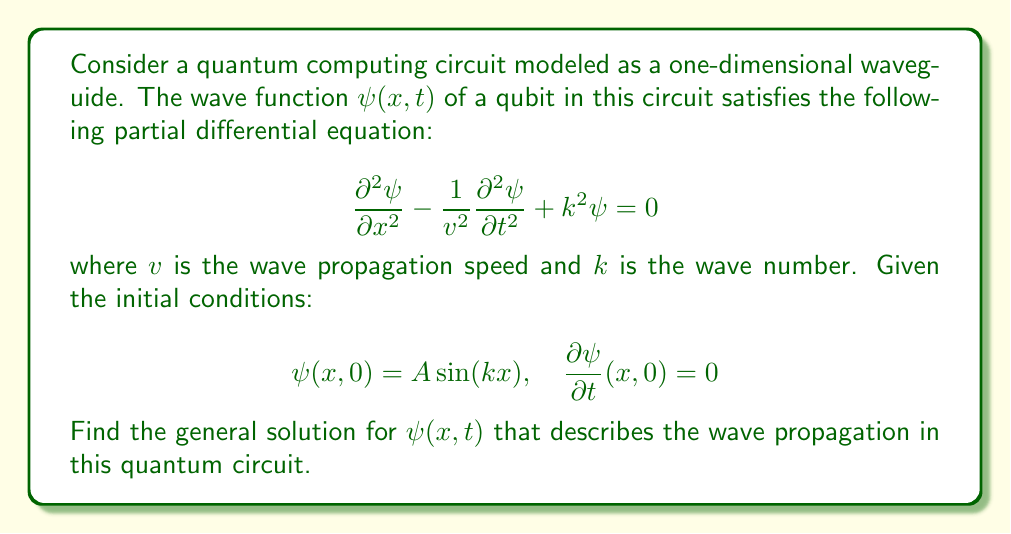Solve this math problem. To solve this problem, we'll follow these steps:

1) First, we recognize this equation as the Klein-Gordon equation, which describes relativistic wave propagation.

2) We can solve this using the method of separation of variables. Let's assume a solution of the form:

   $$\psi(x,t) = X(x)T(t)$$

3) Substituting this into our PDE:

   $$X''T - \frac{1}{v^2}XT'' + k^2XT = 0$$

4) Dividing by $XT$:

   $$\frac{X''}{X} - \frac{1}{v^2}\frac{T''}{T} + k^2 = 0$$

5) Since the left side is a function of $x$ only and the right side is a function of $t$ only, they must both equal a constant. Let's call this constant $-\omega^2$:

   $$\frac{X''}{X} + k^2 = \frac{1}{v^2}\frac{T''}{T} = -\omega^2$$

6) This gives us two ODEs:

   $$X'' + (k^2 + \omega^2)X = 0$$
   $$T'' + v^2\omega^2T = 0$$

7) The general solutions to these are:

   $$X(x) = C_1\sin(\sqrt{k^2 + \omega^2}x) + C_2\cos(\sqrt{k^2 + \omega^2}x)$$
   $$T(t) = C_3\sin(\omega vt) + C_4\cos(\omega vt)$$

8) Therefore, the general solution is:

   $$\psi(x,t) = [A_1\sin(\sqrt{k^2 + \omega^2}x) + A_2\cos(\sqrt{k^2 + \omega^2}x)][B_1\sin(\omega vt) + B_2\cos(\omega vt)]$$

9) Now, we apply the initial conditions. From $\psi(x,0) = A\sin(kx)$, we can deduce:

   $$A_2 = 0, \quad A_1B_2 = A, \quad \sqrt{k^2 + \omega^2} = k$$

10) The last equation implies $\omega = 0$. This simplifies our solution to:

    $$\psi(x,t) = A\sin(kx)\cos(0) = A\sin(kx)$$

11) This solution also satisfies the second initial condition $\frac{\partial \psi}{\partial t}(x,0) = 0$.

Therefore, the wave function doesn't change with time, representing a standing wave in the quantum circuit.
Answer: The general solution for the wave propagation in the quantum circuit is:

$$\psi(x,t) = A\sin(kx)$$

This represents a standing wave in the quantum circuit, where the wave amplitude is constant in time at each point in space. 